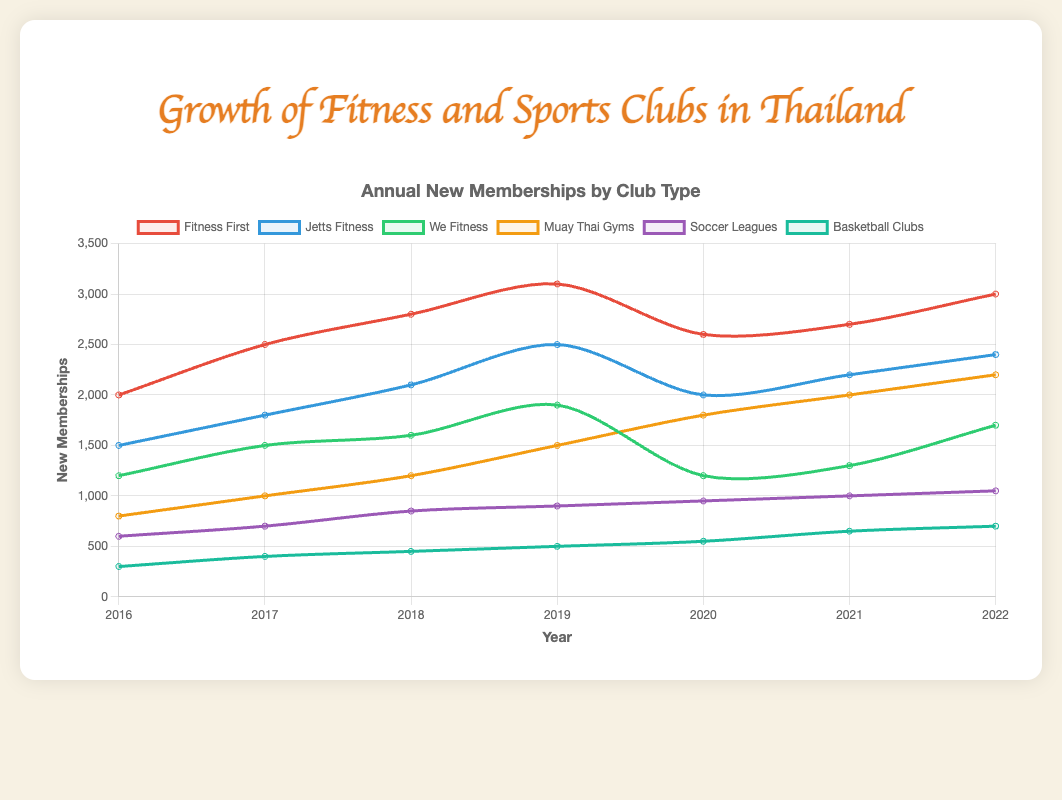Which fitness club had the highest number of new memberships in 2019? Look at the line corresponding to each fitness club in 2019, and note the membership values. Among Fitness First (3100), Jetts Fitness (2500), and We Fitness (1900), Fitness First has the highest number.
Answer: Fitness First How did the number of new memberships for Jetts Fitness in 2021 compare to 2022? Jetts Fitness had 2200 new memberships in 2021 and 2400 in 2022. 2400 is greater than 2200, indicating an increase.
Answer: Increased Which club showed the most consistent growth in new memberships from 2016 to 2022? Examine the trend lines for each club. Muay Thai Gyms show a steady increase each year from 800 in 2016 to 2200 in 2022.
Answer: Muay Thai Gyms What was the combined number of new memberships for Fitness First and We Fitness in 2018? Sum the new memberships for Fitness First (2800) and We Fitness (1600) in 2018. The total is 2800 + 1600 = 4400.
Answer: 4400 Which sports club showed the highest increase in new memberships from 2020 to 2021? Compare the increase in memberships for Muay Thai Gyms (200), Soccer Leagues (50), and Basketball Clubs (100) from 2020 to 2021. Basketball Clubs show the highest increase of 100.
Answer: Basketball Clubs Which two clubs had the smallest difference in new memberships in 2022? Compare the 2022 memberships: Fitness First (3000), Jetts Fitness (2400), We Fitness (1700), Muay Thai Gyms (2200), Soccer Leagues (1050), Basketball Clubs (700). The smallest difference is between Jetts Fitness (2400) and Muay Thai Gyms (2200), which is 200.
Answer: Jetts Fitness and Muay Thai Gyms How did the number of new memberships for Soccer Leagues change from 2016 to 2022? Compare the 2016 new memberships (600) for Soccer Leagues to the 2022 number (1050). Calculate the change: 1050 - 600 = 450, indicating an increase.
Answer: Increased by 450 